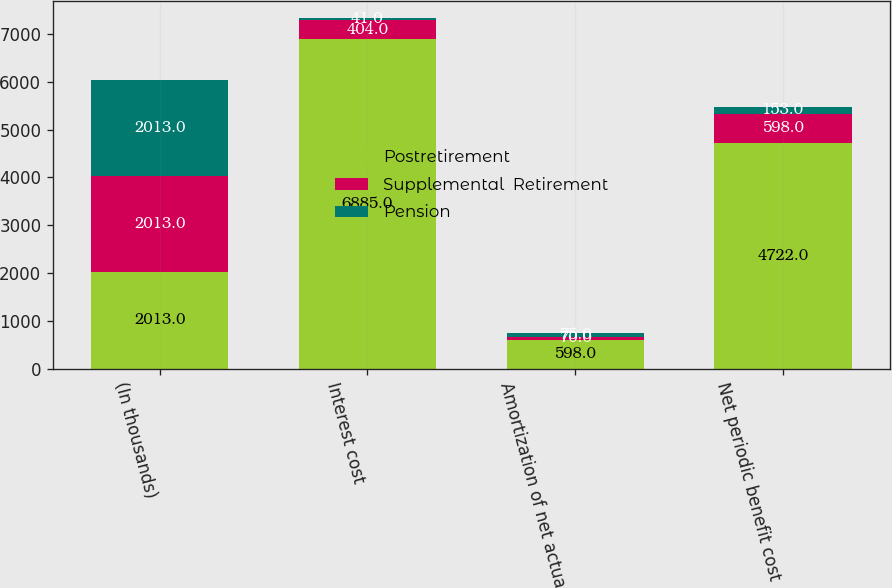Convert chart to OTSL. <chart><loc_0><loc_0><loc_500><loc_500><stacked_bar_chart><ecel><fcel>(In thousands)<fcel>Interest cost<fcel>Amortization of net actuarial<fcel>Net periodic benefit cost<nl><fcel>Postretirement<fcel>2013<fcel>6885<fcel>598<fcel>4722<nl><fcel>Supplemental  Retirement<fcel>2013<fcel>404<fcel>70<fcel>598<nl><fcel>Pension<fcel>2013<fcel>41<fcel>75<fcel>153<nl></chart> 